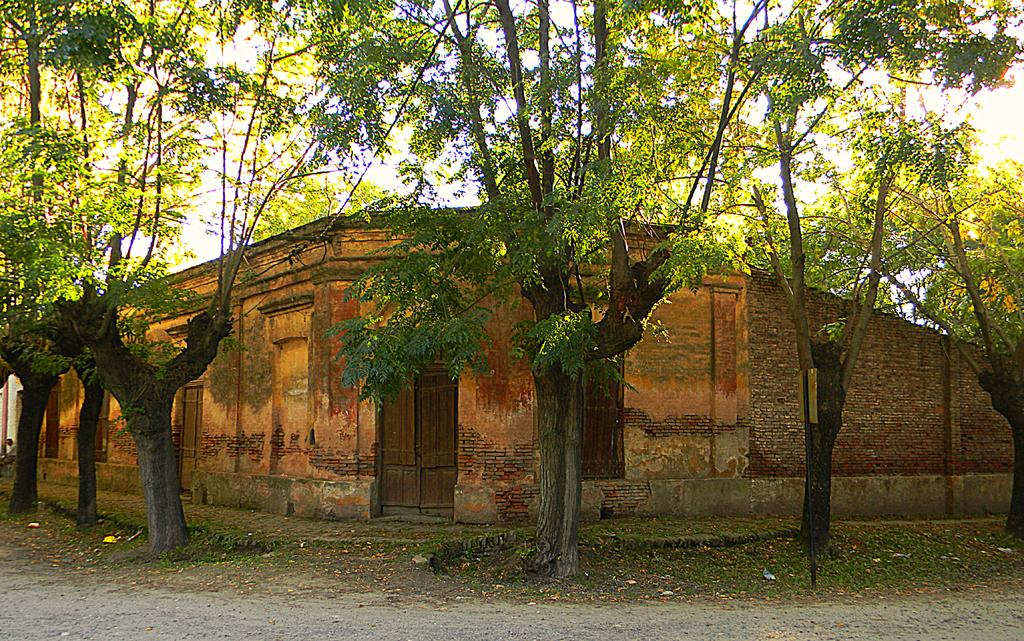What type of vegetation can be seen in the image? There are trees in the image. What color are the trees? The trees are green. What structure is visible in the background of the image? There is a building in the background of the image. What color is the building? The building is brown. What feature of the building is visible in the image? There is a door in the image. What color is the door? The door is brown. What part of the natural environment is visible in the image? The sky is visible in the image. What is the color of the sky in the image? The sky appears white. How many zebras can be seen grazing near the trees in the image? There are no zebras present in the image; it features trees and a building. What type of tax is being discussed in the image? There is no discussion of taxes in the image. 